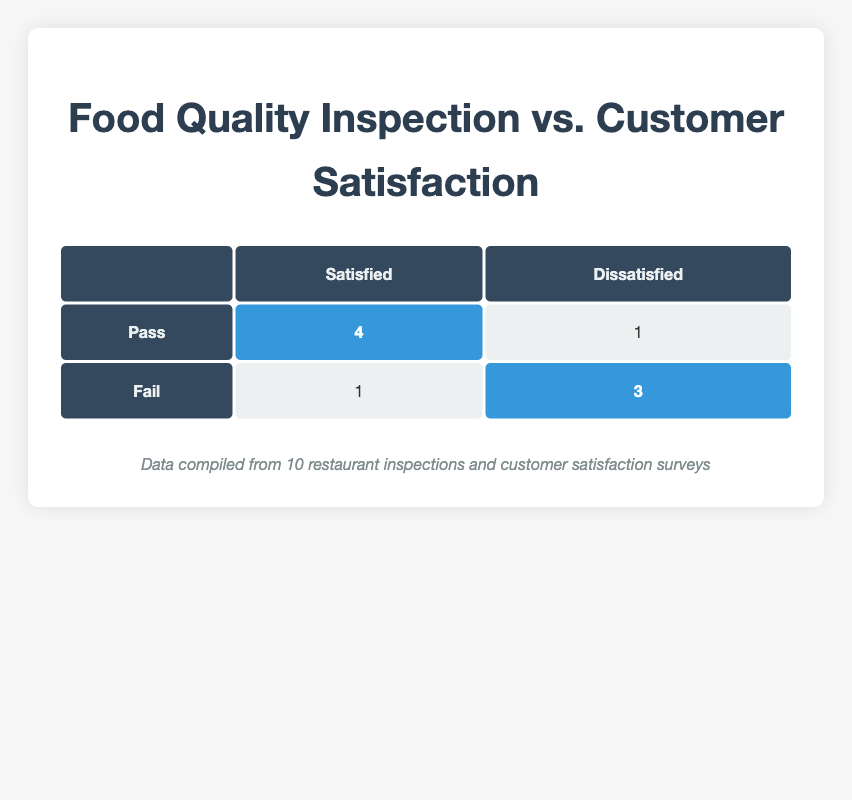What is the total number of restaurants that passed the inspection? The table indicates that there are four restaurants that received a "Pass" inspection result, which is shown directly in the cell under the "Pass" row and "Satisfied" and "Dissatisfied" columns.
Answer: 4 How many restaurants failed the inspection and received a "Satisfied" rating? There is a single restaurant highlighted in the table that has an inspection result of "Fail" and a customer satisfaction rating of "Satisfied", which can be found in the corresponding cell for the "Fail" row and "Satisfied" column.
Answer: 1 What is the total number of dissatisfied customers from restaurants that passed the inspection? The table shows that there is one restaurant that passed inspection and had a "Dissatisfied" customer rating, specifically seen in the "Pass" row and the "Dissatisfied" column. Thus, the total dissatisfied customers from these restaurants is 1.
Answer: 1 Is it true that all failing restaurants had dissatisfied customers? By examining the table, there is one restaurant with a "Fail" inspection result that had a "Satisfied" customer rating, meaning that not all failing restaurants had dissatisfied customers. Therefore, the statement is false.
Answer: No How many more restaurants were "Very Satisfied" compared to those that were dissatisfied regardless of inspection results? First, count the "Very Satisfied" ratings: there are three (from "Spicy Treats", "Quick Eats", and "Urban Bistro"). Then count the total "Dissatisfied" ratings: four (from "Tasty Haven", "Savoury Bites", "Culinary Dreams", "Savory Sensations"). The difference is 3 - 4 = -1.
Answer: -1 What percentage of restaurants that passed inspection were satisfied customers? From the table, 4 restaurants passed inspection, and 4 out of these were satisfied customers (including "Very Satisfied"). Calculation for percentage: (4 satisfied / 4 passed) * 100 = 100%.
Answer: 100% 